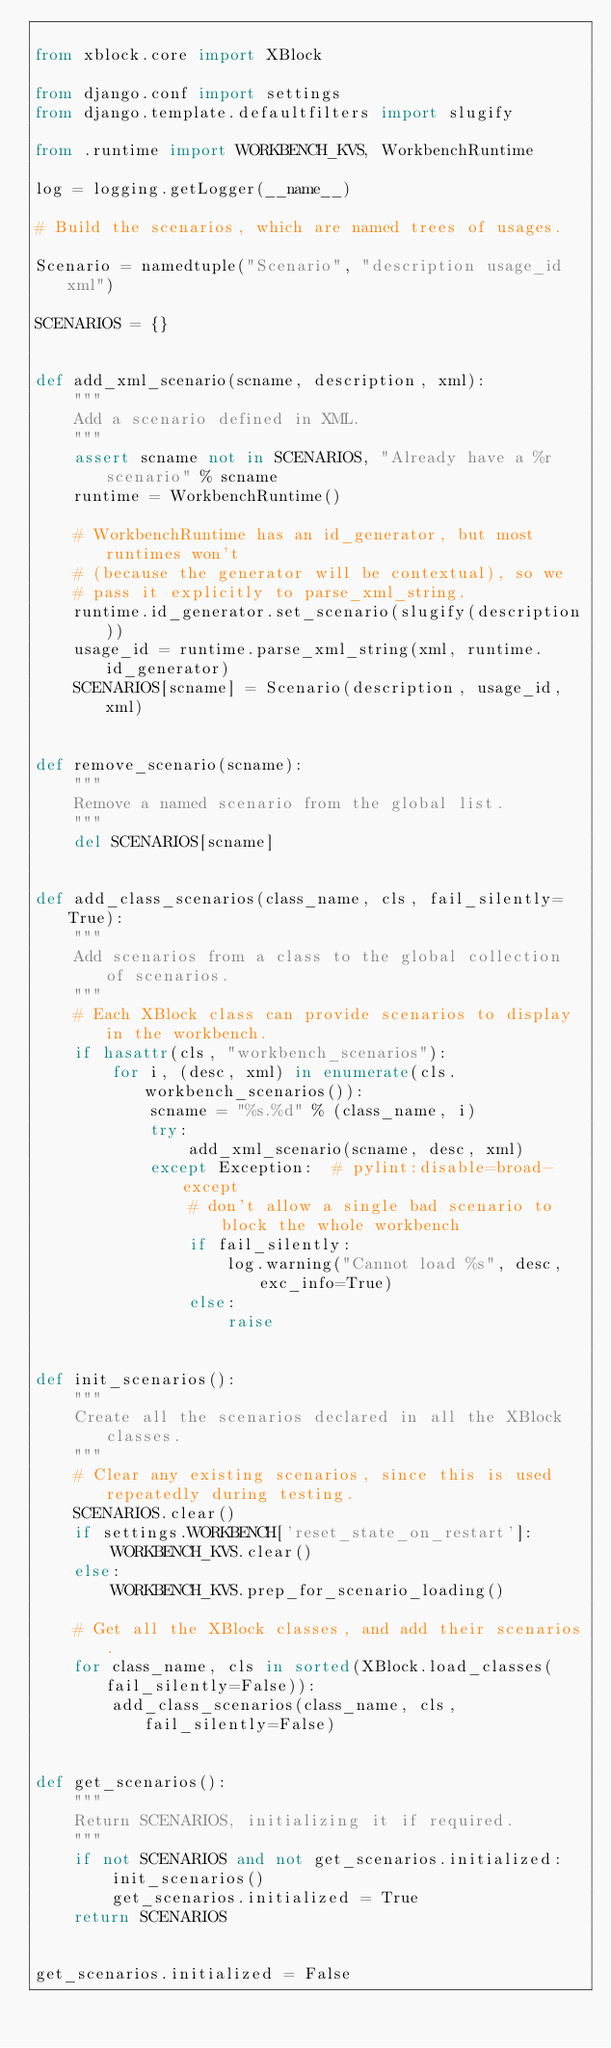Convert code to text. <code><loc_0><loc_0><loc_500><loc_500><_Python_>
from xblock.core import XBlock

from django.conf import settings
from django.template.defaultfilters import slugify

from .runtime import WORKBENCH_KVS, WorkbenchRuntime

log = logging.getLogger(__name__)

# Build the scenarios, which are named trees of usages.

Scenario = namedtuple("Scenario", "description usage_id xml")

SCENARIOS = {}


def add_xml_scenario(scname, description, xml):
    """
    Add a scenario defined in XML.
    """
    assert scname not in SCENARIOS, "Already have a %r scenario" % scname
    runtime = WorkbenchRuntime()

    # WorkbenchRuntime has an id_generator, but most runtimes won't
    # (because the generator will be contextual), so we
    # pass it explicitly to parse_xml_string.
    runtime.id_generator.set_scenario(slugify(description))
    usage_id = runtime.parse_xml_string(xml, runtime.id_generator)
    SCENARIOS[scname] = Scenario(description, usage_id, xml)


def remove_scenario(scname):
    """
    Remove a named scenario from the global list.
    """
    del SCENARIOS[scname]


def add_class_scenarios(class_name, cls, fail_silently=True):
    """
    Add scenarios from a class to the global collection of scenarios.
    """
    # Each XBlock class can provide scenarios to display in the workbench.
    if hasattr(cls, "workbench_scenarios"):
        for i, (desc, xml) in enumerate(cls.workbench_scenarios()):
            scname = "%s.%d" % (class_name, i)
            try:
                add_xml_scenario(scname, desc, xml)
            except Exception:  # pylint:disable=broad-except
                # don't allow a single bad scenario to block the whole workbench
                if fail_silently:
                    log.warning("Cannot load %s", desc, exc_info=True)
                else:
                    raise


def init_scenarios():
    """
    Create all the scenarios declared in all the XBlock classes.
    """
    # Clear any existing scenarios, since this is used repeatedly during testing.
    SCENARIOS.clear()
    if settings.WORKBENCH['reset_state_on_restart']:
        WORKBENCH_KVS.clear()
    else:
        WORKBENCH_KVS.prep_for_scenario_loading()

    # Get all the XBlock classes, and add their scenarios.
    for class_name, cls in sorted(XBlock.load_classes(fail_silently=False)):
        add_class_scenarios(class_name, cls, fail_silently=False)


def get_scenarios():
    """
    Return SCENARIOS, initializing it if required.
    """
    if not SCENARIOS and not get_scenarios.initialized:
        init_scenarios()
        get_scenarios.initialized = True
    return SCENARIOS


get_scenarios.initialized = False
</code> 